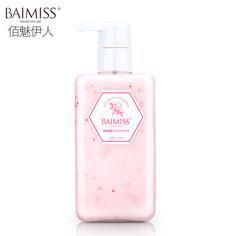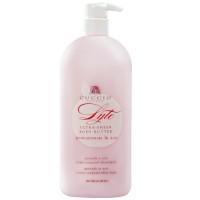The first image is the image on the left, the second image is the image on the right. Considering the images on both sides, is "There are three items." valid? Answer yes or no. No. 